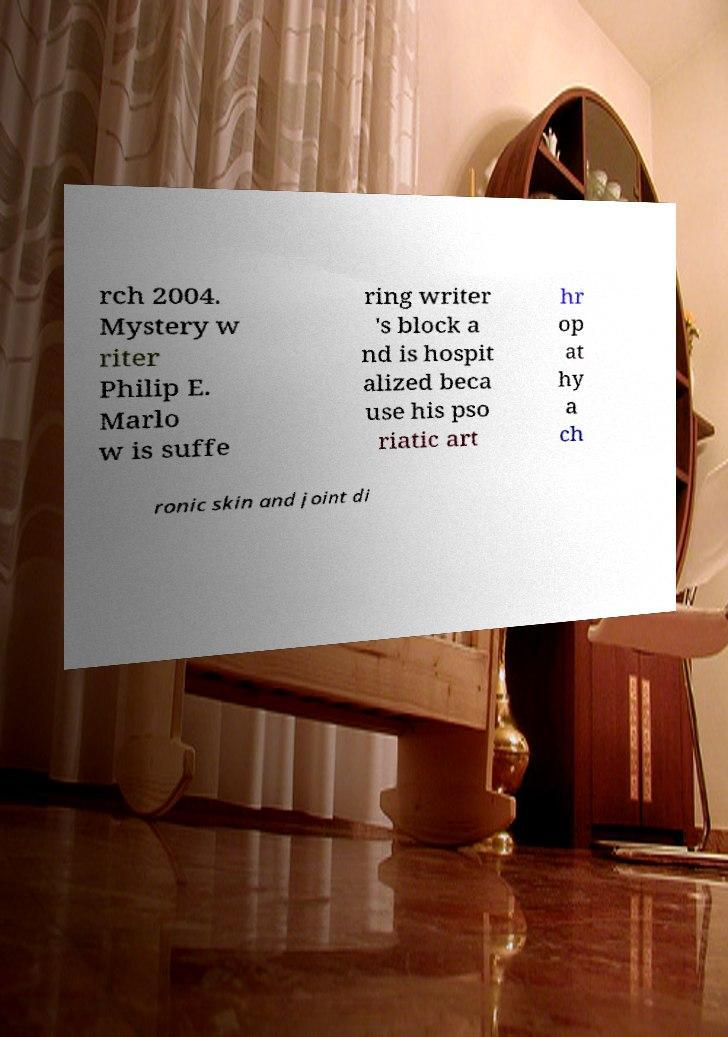Can you accurately transcribe the text from the provided image for me? rch 2004. Mystery w riter Philip E. Marlo w is suffe ring writer 's block a nd is hospit alized beca use his pso riatic art hr op at hy a ch ronic skin and joint di 